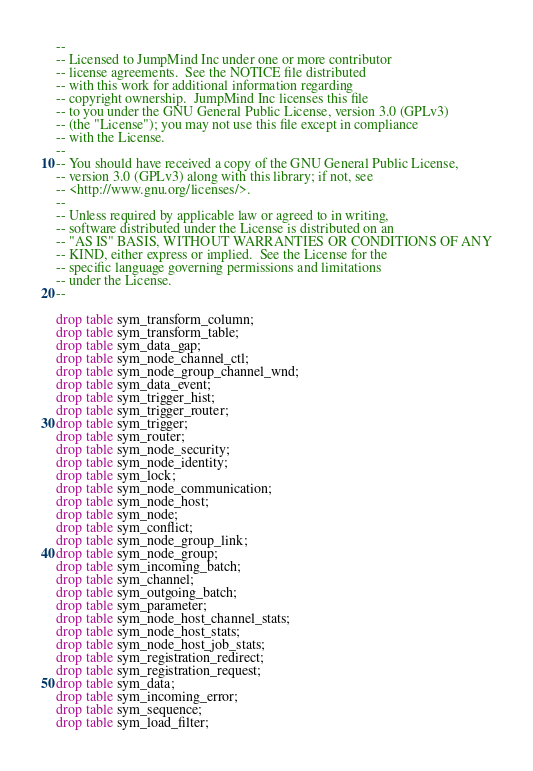<code> <loc_0><loc_0><loc_500><loc_500><_SQL_>--
-- Licensed to JumpMind Inc under one or more contributor
-- license agreements.  See the NOTICE file distributed
-- with this work for additional information regarding
-- copyright ownership.  JumpMind Inc licenses this file
-- to you under the GNU General Public License, version 3.0 (GPLv3)
-- (the "License"); you may not use this file except in compliance
-- with the License.
--
-- You should have received a copy of the GNU General Public License,
-- version 3.0 (GPLv3) along with this library; if not, see
-- <http://www.gnu.org/licenses/>.
--
-- Unless required by applicable law or agreed to in writing,
-- software distributed under the License is distributed on an
-- "AS IS" BASIS, WITHOUT WARRANTIES OR CONDITIONS OF ANY
-- KIND, either express or implied.  See the License for the
-- specific language governing permissions and limitations
-- under the License.
--

drop table sym_transform_column;
drop table sym_transform_table;
drop table sym_data_gap;
drop table sym_node_channel_ctl;
drop table sym_node_group_channel_wnd;
drop table sym_data_event;
drop table sym_trigger_hist;
drop table sym_trigger_router;
drop table sym_trigger;
drop table sym_router;
drop table sym_node_security;
drop table sym_node_identity;
drop table sym_lock;
drop table sym_node_communication;
drop table sym_node_host;
drop table sym_node;
drop table sym_conflict;
drop table sym_node_group_link;
drop table sym_node_group;
drop table sym_incoming_batch;
drop table sym_channel;
drop table sym_outgoing_batch;
drop table sym_parameter;
drop table sym_node_host_channel_stats;
drop table sym_node_host_stats;
drop table sym_node_host_job_stats;
drop table sym_registration_redirect;
drop table sym_registration_request;
drop table sym_data;
drop table sym_incoming_error;
drop table sym_sequence;
drop table sym_load_filter;</code> 